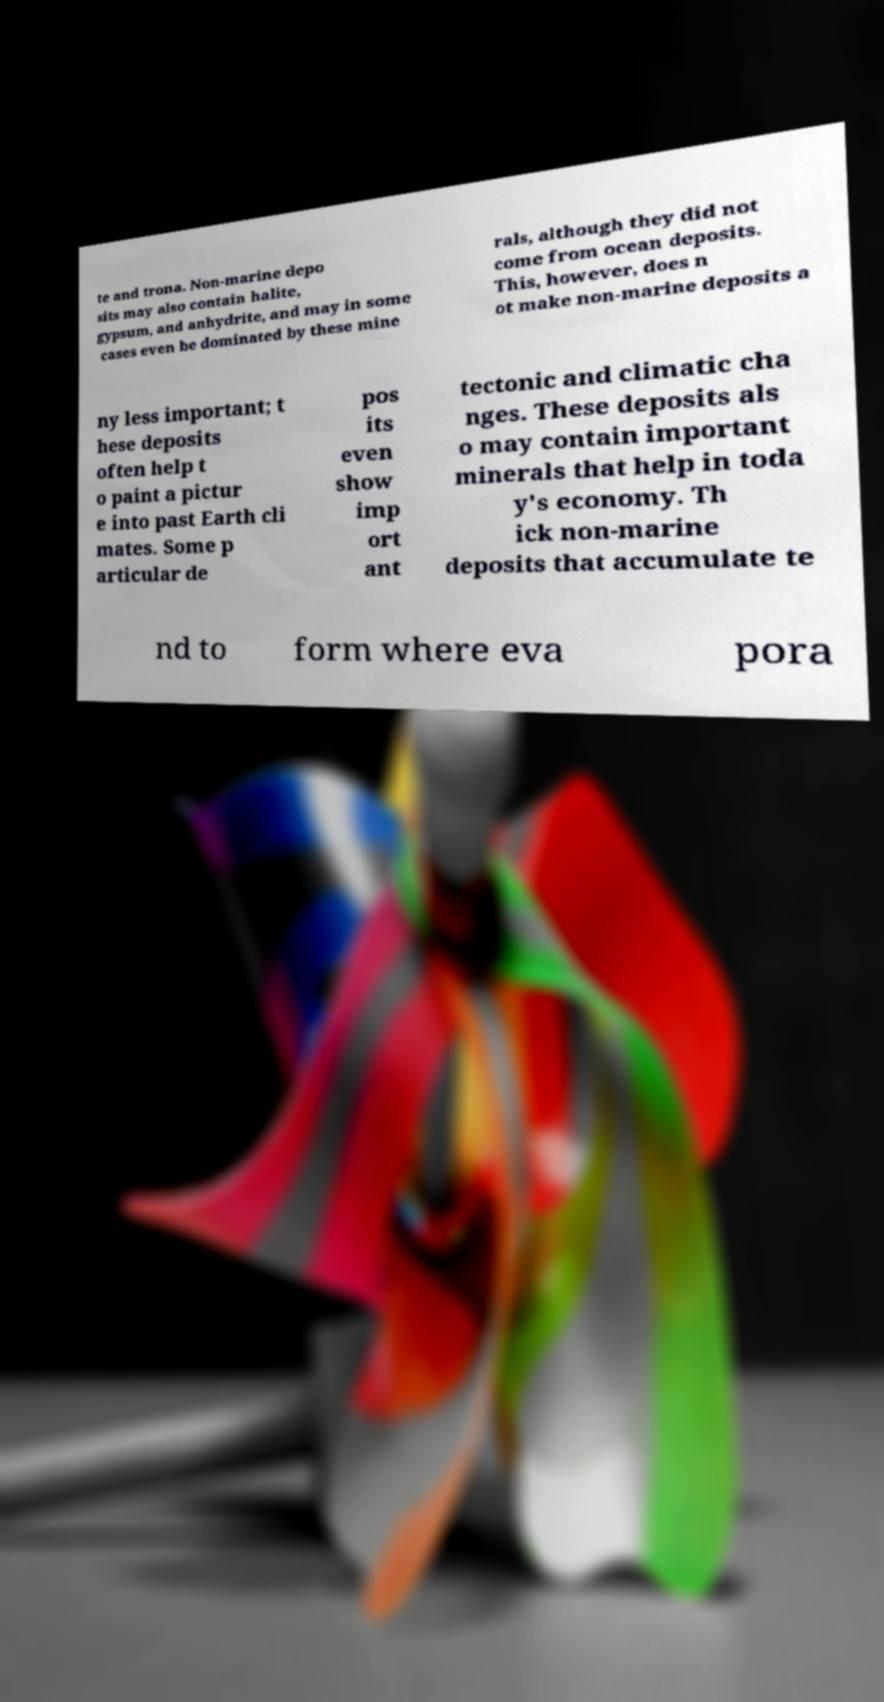Can you read and provide the text displayed in the image?This photo seems to have some interesting text. Can you extract and type it out for me? te and trona. Non-marine depo sits may also contain halite, gypsum, and anhydrite, and may in some cases even be dominated by these mine rals, although they did not come from ocean deposits. This, however, does n ot make non-marine deposits a ny less important; t hese deposits often help t o paint a pictur e into past Earth cli mates. Some p articular de pos its even show imp ort ant tectonic and climatic cha nges. These deposits als o may contain important minerals that help in toda y's economy. Th ick non-marine deposits that accumulate te nd to form where eva pora 